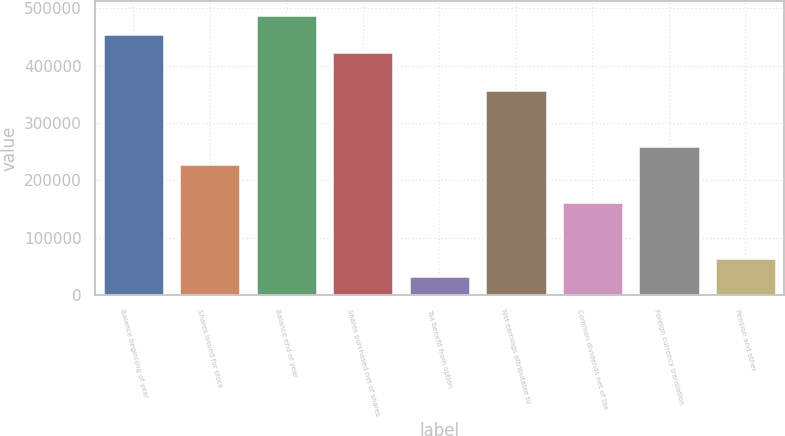Convert chart. <chart><loc_0><loc_0><loc_500><loc_500><bar_chart><fcel>Balance beginning of year<fcel>Shares issued for stock<fcel>Balance end of year<fcel>Shares purchased net of shares<fcel>Tax benefit from option<fcel>Net earnings attributable to<fcel>Common dividends net of tax<fcel>Foreign currency translation<fcel>Pension and other<nl><fcel>455590<fcel>227798<fcel>488132<fcel>423048<fcel>32547.2<fcel>357965<fcel>162714<fcel>260340<fcel>65089<nl></chart> 